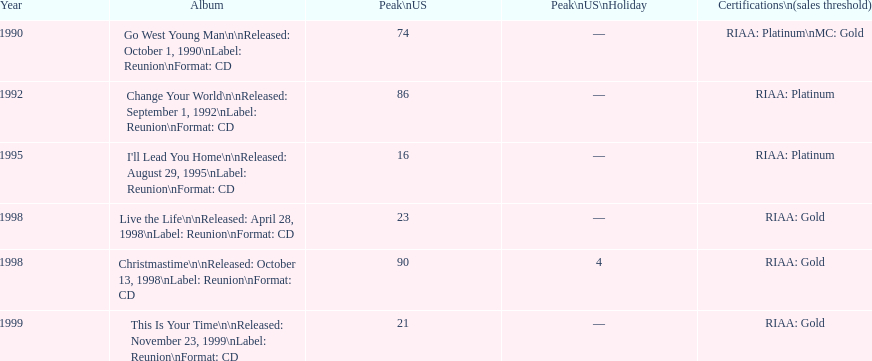In the us, which album had the smallest peak on the charts? I'll Lead You Home. 